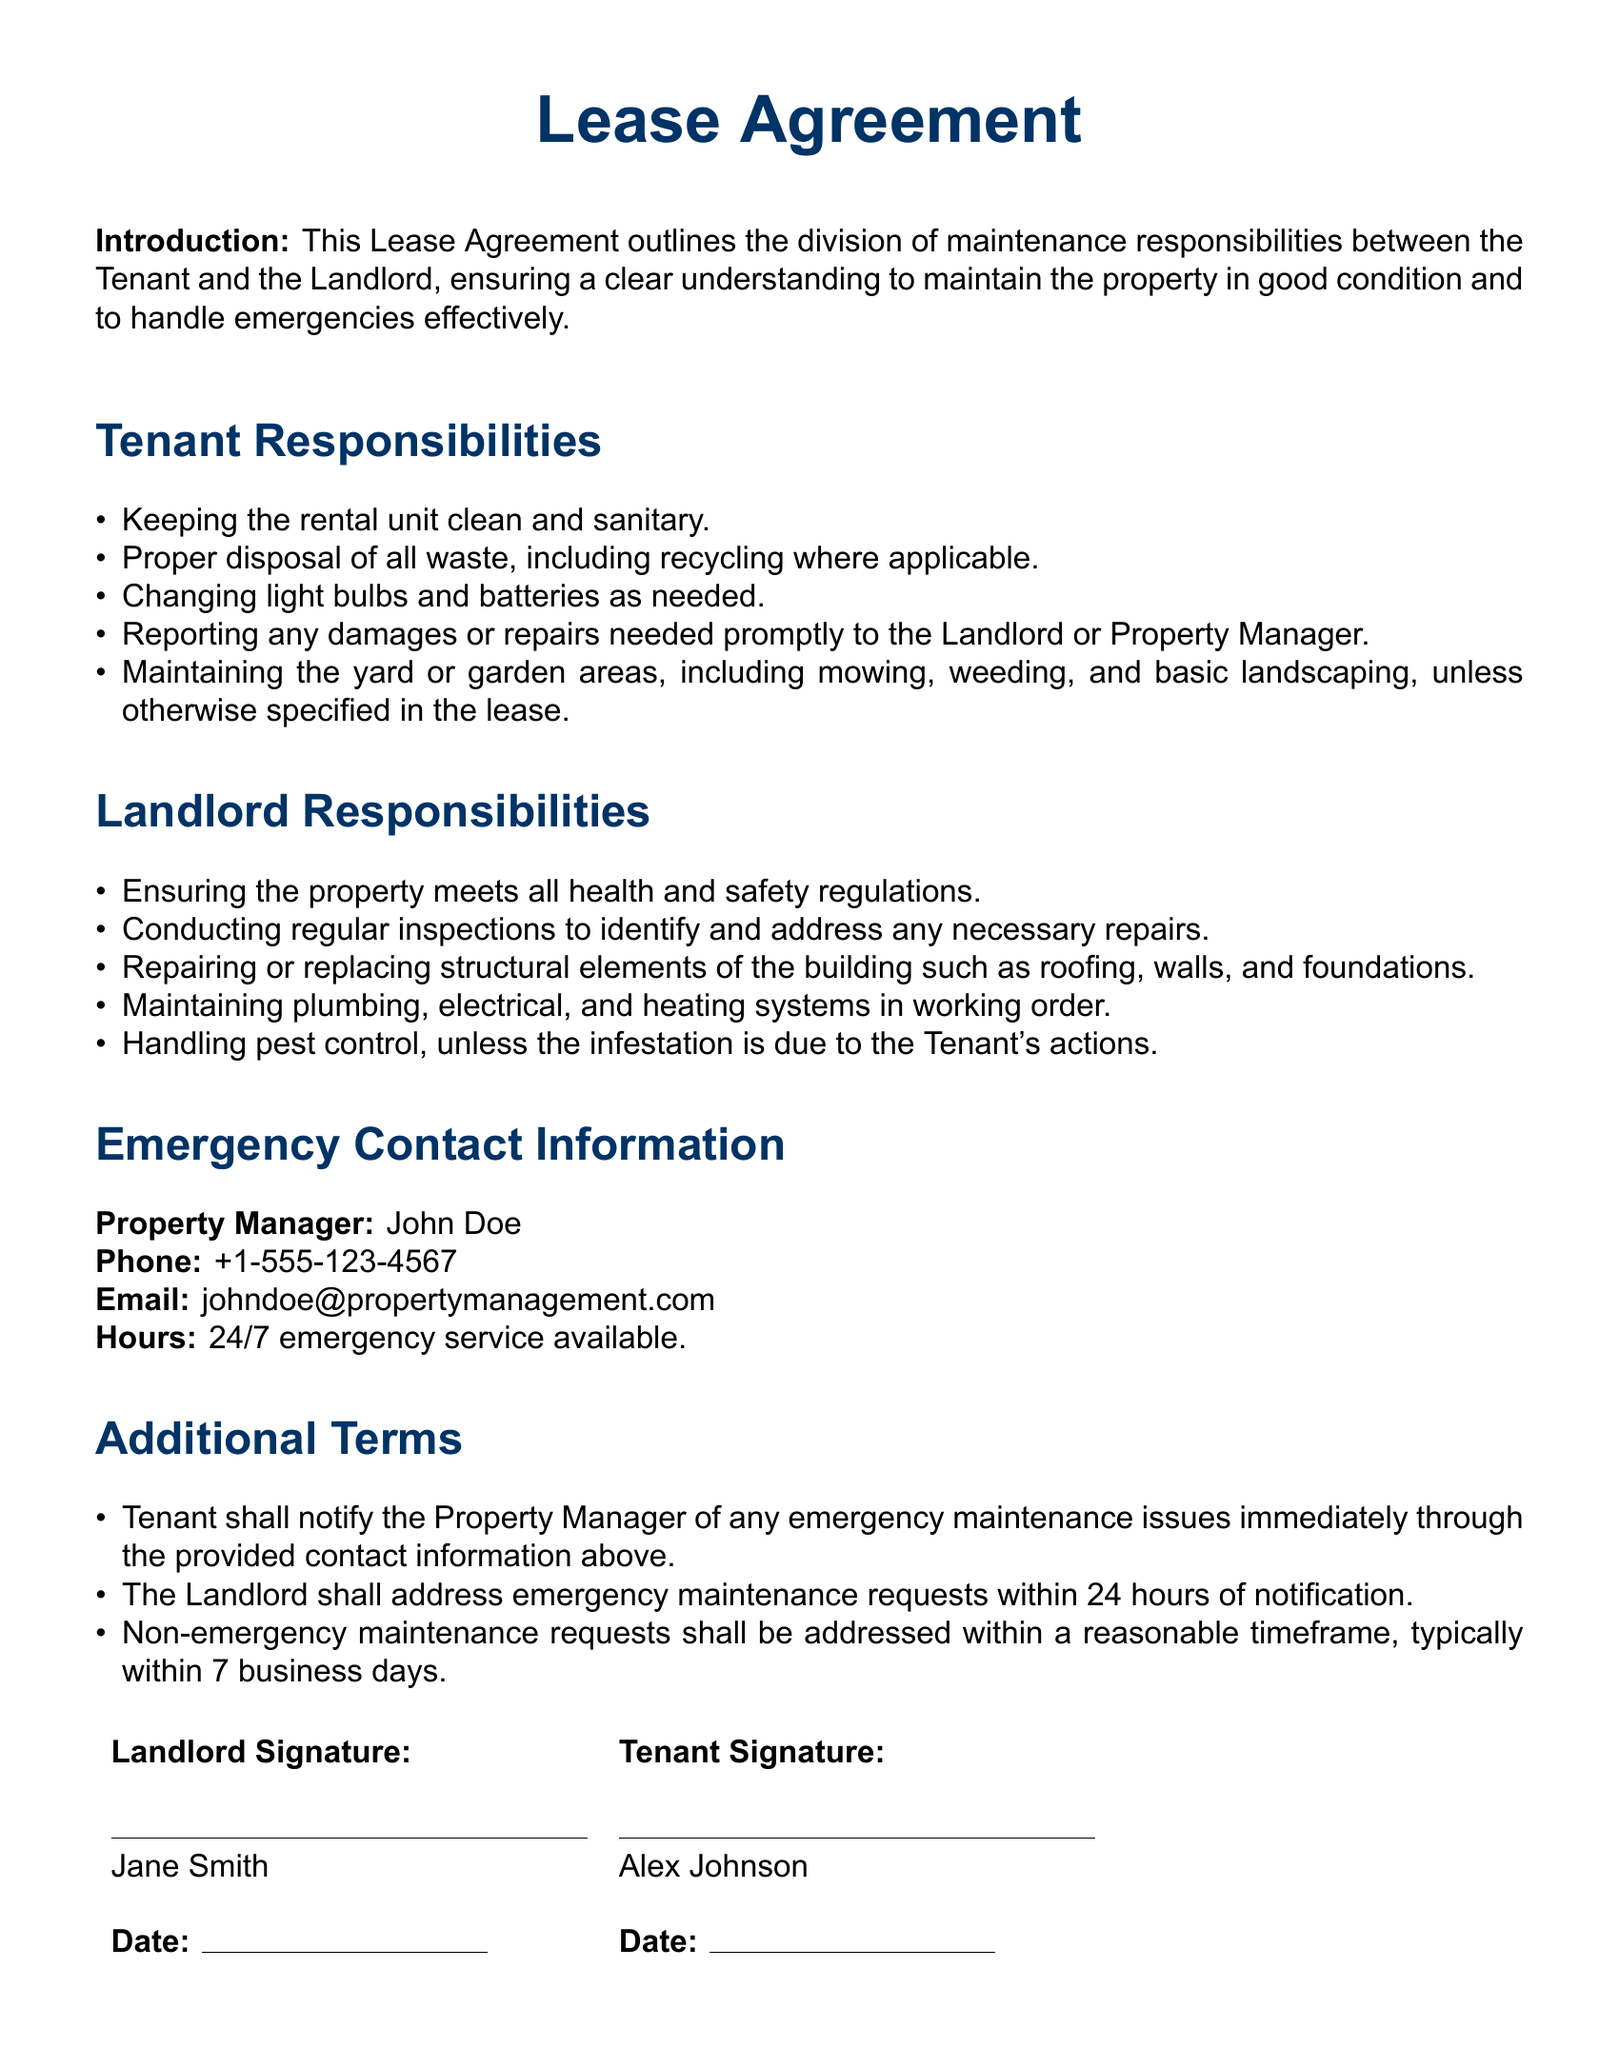What is the tenant's first responsibility? The tenant's first responsibility is to keep the rental unit clean and sanitary.
Answer: Keeping the rental unit clean and sanitary What is the property manager's name? The property manager's name is listed in the emergency contact information section.
Answer: John Doe What is the phone number for the property manager? The phone number for the property manager is specified in the document.
Answer: +1-555-123-4567 How soon must the landlord address emergency maintenance requests? The document indicates the timeframe for the landlord's response to emergency maintenance requests.
Answer: Within 24 hours Who is responsible for maintaining plumbing and electrical systems? The responsibilities regarding maintenance of plumbing and electrical systems are mentioned under landlord responsibilities.
Answer: Landlord What is the tenant responsible for regarding waste disposal? The document specifies the tenant's obligations concerning waste disposal.
Answer: Proper disposal of all waste What must the tenant do if they notice a need for repairs? This question refers to the tenant's obligations regarding reporting damages.
Answer: Reporting any damages or repairs needed promptly What kind of service is available 24/7? The document states specific emergency services offered by the property manager.
Answer: Emergency service 